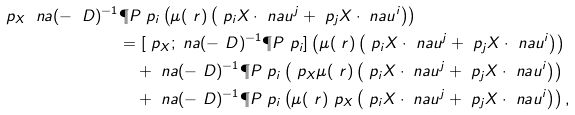<formula> <loc_0><loc_0><loc_500><loc_500>\ p _ { X } \ n a ( - \ D ) ^ { - 1 } & \P P \ p _ { i } \left ( \mu ( \ r ) \left ( \ p _ { i } X \cdot \ n a u ^ { j } + \ p _ { j } X \cdot \ n a u ^ { i } \right ) \right ) \\ & = [ \ p _ { X } ; \ n a ( - \ D ) ^ { - 1 } \P P \ p _ { i } ] \left ( \mu ( \ r ) \left ( \ p _ { i } X \cdot \ n a u ^ { j } + \ p _ { j } X \cdot \ n a u ^ { i } \right ) \right ) \\ & \quad + \ n a ( - \ D ) ^ { - 1 } \P P \ p _ { i } \left ( \ p _ { X } \mu ( \ r ) \left ( \ p _ { i } X \cdot \ n a u ^ { j } + \ p _ { j } X \cdot \ n a u ^ { i } \right ) \right ) \\ & \quad + \ n a ( - \ D ) ^ { - 1 } \P P \ p _ { i } \left ( \mu ( \ r ) \ p _ { X } \left ( \ p _ { i } X \cdot \ n a u ^ { j } + \ p _ { j } X \cdot \ n a u ^ { i } \right ) \right ) ,</formula> 